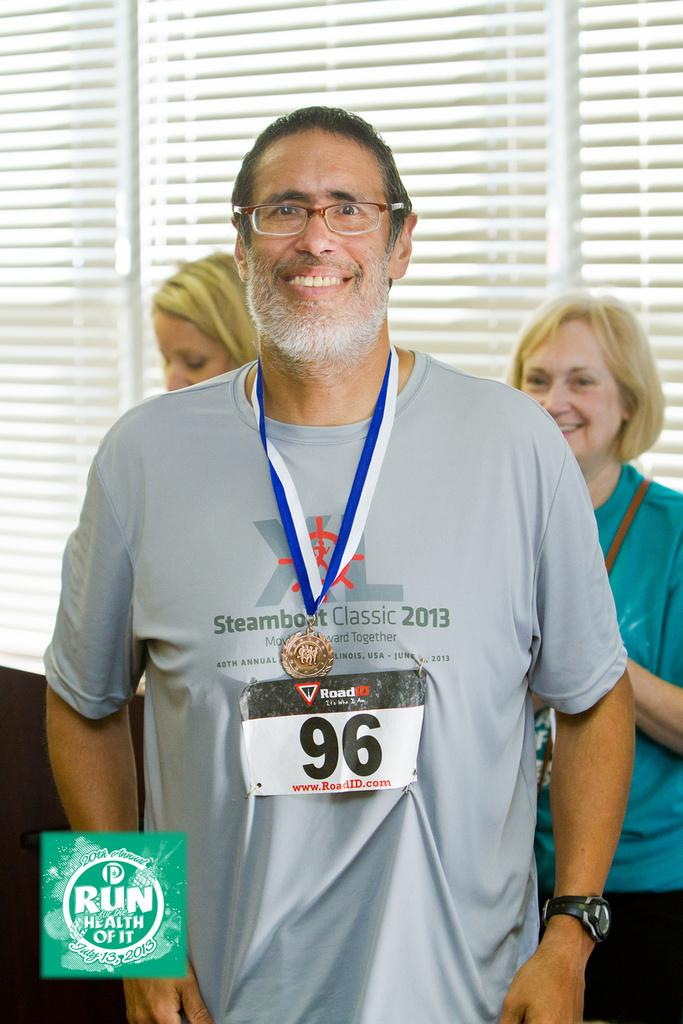<image>
Give a short and clear explanation of the subsequent image. A man with the number 96 pinned to his shirt is wearing a medal. 